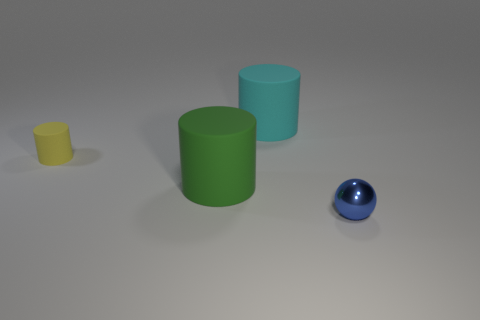Subtract all green rubber cylinders. How many cylinders are left? 2 Add 2 green cylinders. How many objects exist? 6 Subtract all yellow cylinders. How many cylinders are left? 2 Subtract 1 cylinders. How many cylinders are left? 2 Add 2 big green rubber objects. How many big green rubber objects are left? 3 Add 1 green balls. How many green balls exist? 1 Subtract 0 gray blocks. How many objects are left? 4 Subtract all balls. How many objects are left? 3 Subtract all green cylinders. Subtract all blue spheres. How many cylinders are left? 2 Subtract all cyan balls. How many green cylinders are left? 1 